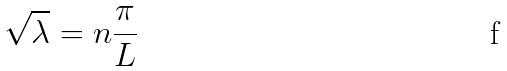<formula> <loc_0><loc_0><loc_500><loc_500>\sqrt { \lambda } = n \frac { \pi } { L }</formula> 